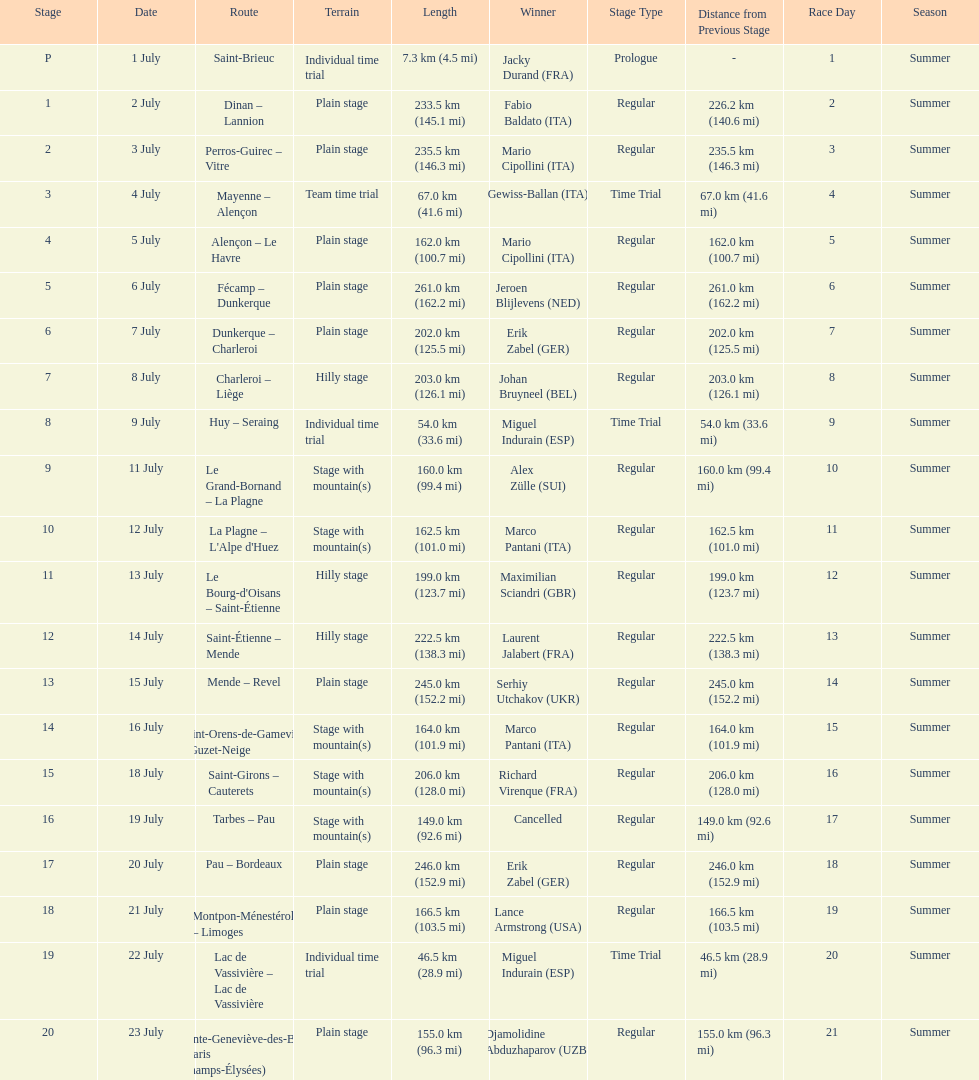How many stages were at least 200 km in length in the 1995 tour de france? 9. Write the full table. {'header': ['Stage', 'Date', 'Route', 'Terrain', 'Length', 'Winner', 'Stage Type', 'Distance from Previous Stage', 'Race Day', 'Season'], 'rows': [['P', '1 July', 'Saint-Brieuc', 'Individual time trial', '7.3\xa0km (4.5\xa0mi)', 'Jacky Durand\xa0(FRA)', 'Prologue', '-', '1', 'Summer'], ['1', '2 July', 'Dinan – Lannion', 'Plain stage', '233.5\xa0km (145.1\xa0mi)', 'Fabio Baldato\xa0(ITA)', 'Regular', '226.2 km (140.6 mi)', '2', 'Summer'], ['2', '3 July', 'Perros-Guirec – Vitre', 'Plain stage', '235.5\xa0km (146.3\xa0mi)', 'Mario Cipollini\xa0(ITA)', 'Regular', '235.5 km (146.3 mi)', '3', 'Summer'], ['3', '4 July', 'Mayenne – Alençon', 'Team time trial', '67.0\xa0km (41.6\xa0mi)', 'Gewiss-Ballan\xa0(ITA)', 'Time Trial', '67.0 km (41.6 mi)', '4', 'Summer'], ['4', '5 July', 'Alençon – Le Havre', 'Plain stage', '162.0\xa0km (100.7\xa0mi)', 'Mario Cipollini\xa0(ITA)', 'Regular', '162.0 km (100.7 mi)', '5', 'Summer'], ['5', '6 July', 'Fécamp – Dunkerque', 'Plain stage', '261.0\xa0km (162.2\xa0mi)', 'Jeroen Blijlevens\xa0(NED)', 'Regular', '261.0 km (162.2 mi)', '6', 'Summer'], ['6', '7 July', 'Dunkerque – Charleroi', 'Plain stage', '202.0\xa0km (125.5\xa0mi)', 'Erik Zabel\xa0(GER)', 'Regular', '202.0 km (125.5 mi)', '7', 'Summer'], ['7', '8 July', 'Charleroi – Liège', 'Hilly stage', '203.0\xa0km (126.1\xa0mi)', 'Johan Bruyneel\xa0(BEL)', 'Regular', '203.0 km (126.1 mi)', '8', 'Summer'], ['8', '9 July', 'Huy – Seraing', 'Individual time trial', '54.0\xa0km (33.6\xa0mi)', 'Miguel Indurain\xa0(ESP)', 'Time Trial', '54.0 km (33.6 mi)', '9', 'Summer'], ['9', '11 July', 'Le Grand-Bornand – La Plagne', 'Stage with mountain(s)', '160.0\xa0km (99.4\xa0mi)', 'Alex Zülle\xa0(SUI)', 'Regular', '160.0 km (99.4 mi)', '10', 'Summer'], ['10', '12 July', "La Plagne – L'Alpe d'Huez", 'Stage with mountain(s)', '162.5\xa0km (101.0\xa0mi)', 'Marco Pantani\xa0(ITA)', 'Regular', '162.5 km (101.0 mi)', '11', 'Summer'], ['11', '13 July', "Le Bourg-d'Oisans – Saint-Étienne", 'Hilly stage', '199.0\xa0km (123.7\xa0mi)', 'Maximilian Sciandri\xa0(GBR)', 'Regular', '199.0 km (123.7 mi)', '12', 'Summer'], ['12', '14 July', 'Saint-Étienne – Mende', 'Hilly stage', '222.5\xa0km (138.3\xa0mi)', 'Laurent Jalabert\xa0(FRA)', 'Regular', '222.5 km (138.3 mi)', '13', 'Summer'], ['13', '15 July', 'Mende – Revel', 'Plain stage', '245.0\xa0km (152.2\xa0mi)', 'Serhiy Utchakov\xa0(UKR)', 'Regular', '245.0 km (152.2 mi)', '14', 'Summer'], ['14', '16 July', 'Saint-Orens-de-Gameville – Guzet-Neige', 'Stage with mountain(s)', '164.0\xa0km (101.9\xa0mi)', 'Marco Pantani\xa0(ITA)', 'Regular', '164.0 km (101.9 mi)', '15', 'Summer'], ['15', '18 July', 'Saint-Girons – Cauterets', 'Stage with mountain(s)', '206.0\xa0km (128.0\xa0mi)', 'Richard Virenque\xa0(FRA)', 'Regular', '206.0 km (128.0 mi)', '16', 'Summer'], ['16', '19 July', 'Tarbes – Pau', 'Stage with mountain(s)', '149.0\xa0km (92.6\xa0mi)', 'Cancelled', 'Regular', '149.0 km (92.6 mi)', '17', 'Summer'], ['17', '20 July', 'Pau – Bordeaux', 'Plain stage', '246.0\xa0km (152.9\xa0mi)', 'Erik Zabel\xa0(GER)', 'Regular', '246.0 km (152.9 mi)', '18', 'Summer'], ['18', '21 July', 'Montpon-Ménestérol – Limoges', 'Plain stage', '166.5\xa0km (103.5\xa0mi)', 'Lance Armstrong\xa0(USA)', 'Regular', '166.5 km (103.5 mi)', '19', 'Summer'], ['19', '22 July', 'Lac de Vassivière – Lac de Vassivière', 'Individual time trial', '46.5\xa0km (28.9\xa0mi)', 'Miguel Indurain\xa0(ESP)', 'Time Trial', '46.5 km (28.9 mi)', '20', 'Summer'], ['20', '23 July', 'Sainte-Geneviève-des-Bois – Paris (Champs-Élysées)', 'Plain stage', '155.0\xa0km (96.3\xa0mi)', 'Djamolidine Abduzhaparov\xa0(UZB)', 'Regular', '155.0 km (96.3 mi)', '21', 'Summer']]} 